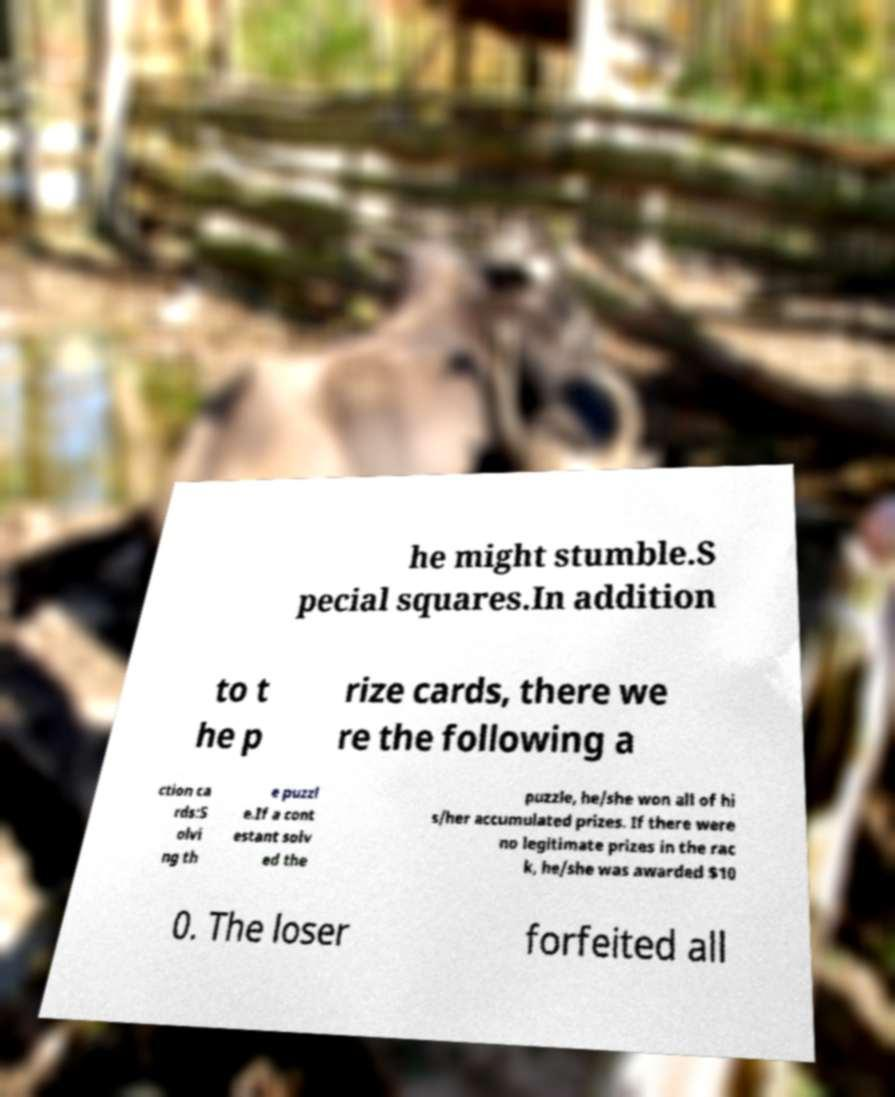Could you extract and type out the text from this image? he might stumble.S pecial squares.In addition to t he p rize cards, there we re the following a ction ca rds:S olvi ng th e puzzl e.If a cont estant solv ed the puzzle, he/she won all of hi s/her accumulated prizes. If there were no legitimate prizes in the rac k, he/she was awarded $10 0. The loser forfeited all 